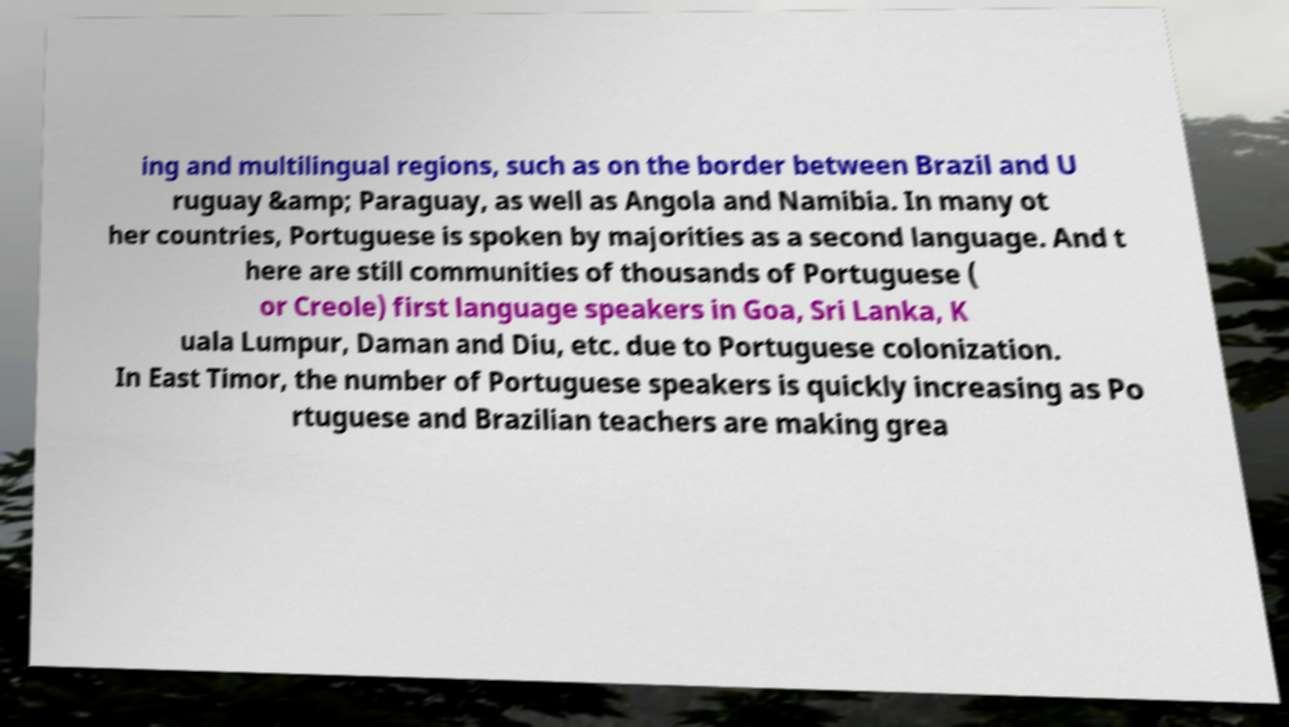What messages or text are displayed in this image? I need them in a readable, typed format. ing and multilingual regions, such as on the border between Brazil and U ruguay &amp; Paraguay, as well as Angola and Namibia. In many ot her countries, Portuguese is spoken by majorities as a second language. And t here are still communities of thousands of Portuguese ( or Creole) first language speakers in Goa, Sri Lanka, K uala Lumpur, Daman and Diu, etc. due to Portuguese colonization. In East Timor, the number of Portuguese speakers is quickly increasing as Po rtuguese and Brazilian teachers are making grea 